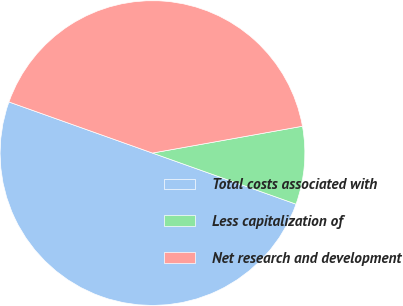Convert chart to OTSL. <chart><loc_0><loc_0><loc_500><loc_500><pie_chart><fcel>Total costs associated with<fcel>Less capitalization of<fcel>Net research and development<nl><fcel>50.0%<fcel>8.26%<fcel>41.74%<nl></chart> 